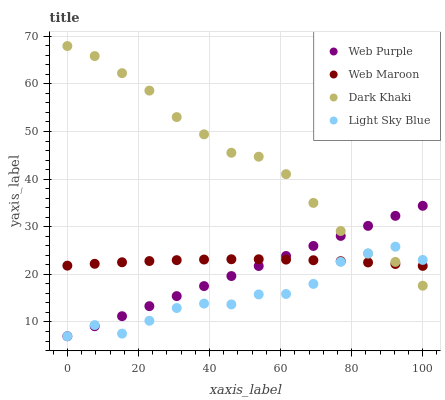Does Light Sky Blue have the minimum area under the curve?
Answer yes or no. Yes. Does Dark Khaki have the maximum area under the curve?
Answer yes or no. Yes. Does Web Purple have the minimum area under the curve?
Answer yes or no. No. Does Web Purple have the maximum area under the curve?
Answer yes or no. No. Is Web Purple the smoothest?
Answer yes or no. Yes. Is Light Sky Blue the roughest?
Answer yes or no. Yes. Is Light Sky Blue the smoothest?
Answer yes or no. No. Is Web Purple the roughest?
Answer yes or no. No. Does Web Purple have the lowest value?
Answer yes or no. Yes. Does Web Maroon have the lowest value?
Answer yes or no. No. Does Dark Khaki have the highest value?
Answer yes or no. Yes. Does Web Purple have the highest value?
Answer yes or no. No. Does Web Maroon intersect Dark Khaki?
Answer yes or no. Yes. Is Web Maroon less than Dark Khaki?
Answer yes or no. No. Is Web Maroon greater than Dark Khaki?
Answer yes or no. No. 